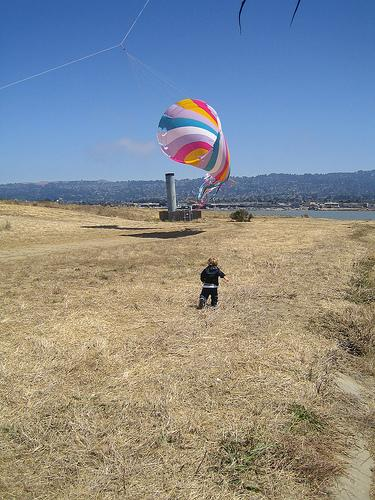What activities are happening in the image and where? A child is running on dried grass, as a multicolored kite flies high in the sky above a building, and shadows cast on the ground in the field. Describe the various plant life and terrain visible in the image. The field features brown grass, dead brown ground surface, and a green bush amidst a landscape of bodies of water, trees, and a hazy hill. Write a description focusing on the colors visible in the image. A blue body of water, green bush, and dry brown grass contrast in the landscape, while a colorful kite soars in the clear blue sky with a thin white cloud. Mention the key objects and their characteristics in the image. A toddler with light-colored hair runs in the grass, while a cylinder-shaped kite with pink swirls hovers above, near a building with a gray smoke stack. Point out the major elements in the environment and their locations in relation to each other. A toddler runs amidst brown grass near a green bush, with a building and silver stack in the distance, a multicolored kite floating in the sky, and water with a shoreline beyond the field. Write a brief summary of the scene depicted in the image. A child joyfully runs on a field of dried grass with a vibrant kite in the air, surrounded by nature and a distant building and smokestack. What are the interesting features of the objects present in the image? A child wears a dark shirt and pants, a colorful kite has flowing tails and many strings, and a silver stack is attached to a gray power plant tower. Mention the most prominent object in the image and its surroundings. A toddler with blonde hair is running on dead brown grass, with a multicolored kite flying overhead and a silver stack and building in the background. Write a concise description of the main subject and its context. A child plays on dried grass with a colorful kite above, surrounded by a blue body of water, trees on a hill, and a distant building. Describe the setting of the image, including the time of day and the landscape. It's a bright, clear day with blue skies as a child plays on a field of brown and green grass surrounded by trees, a body of water, and a power plant tower. 